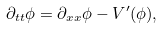<formula> <loc_0><loc_0><loc_500><loc_500>\partial _ { t t } \phi = \partial _ { x x } \phi - V ^ { \prime } ( \phi ) ,</formula> 